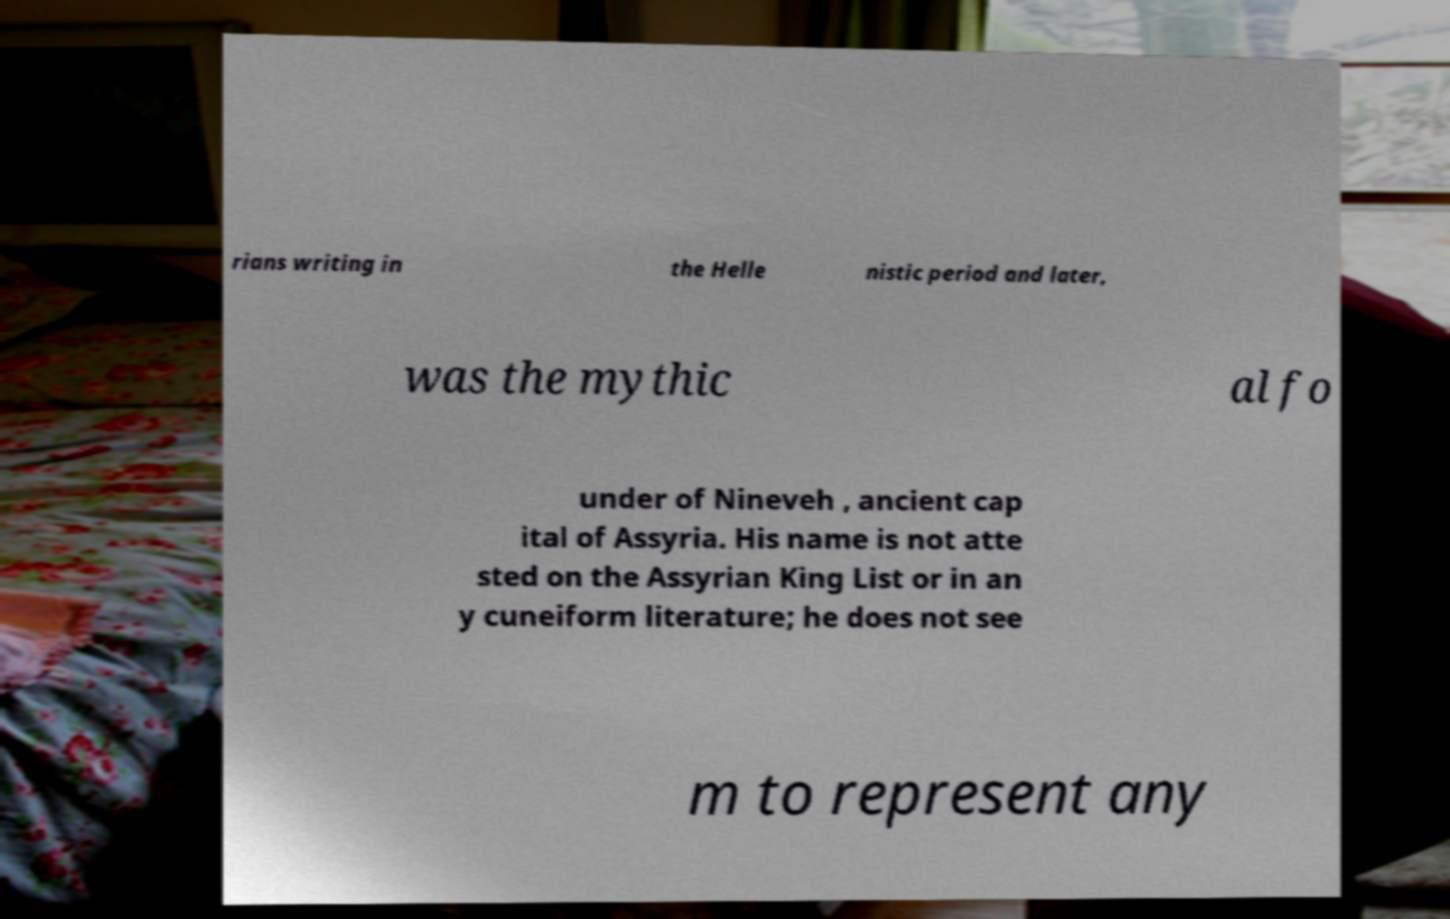Could you assist in decoding the text presented in this image and type it out clearly? rians writing in the Helle nistic period and later, was the mythic al fo under of Nineveh , ancient cap ital of Assyria. His name is not atte sted on the Assyrian King List or in an y cuneiform literature; he does not see m to represent any 